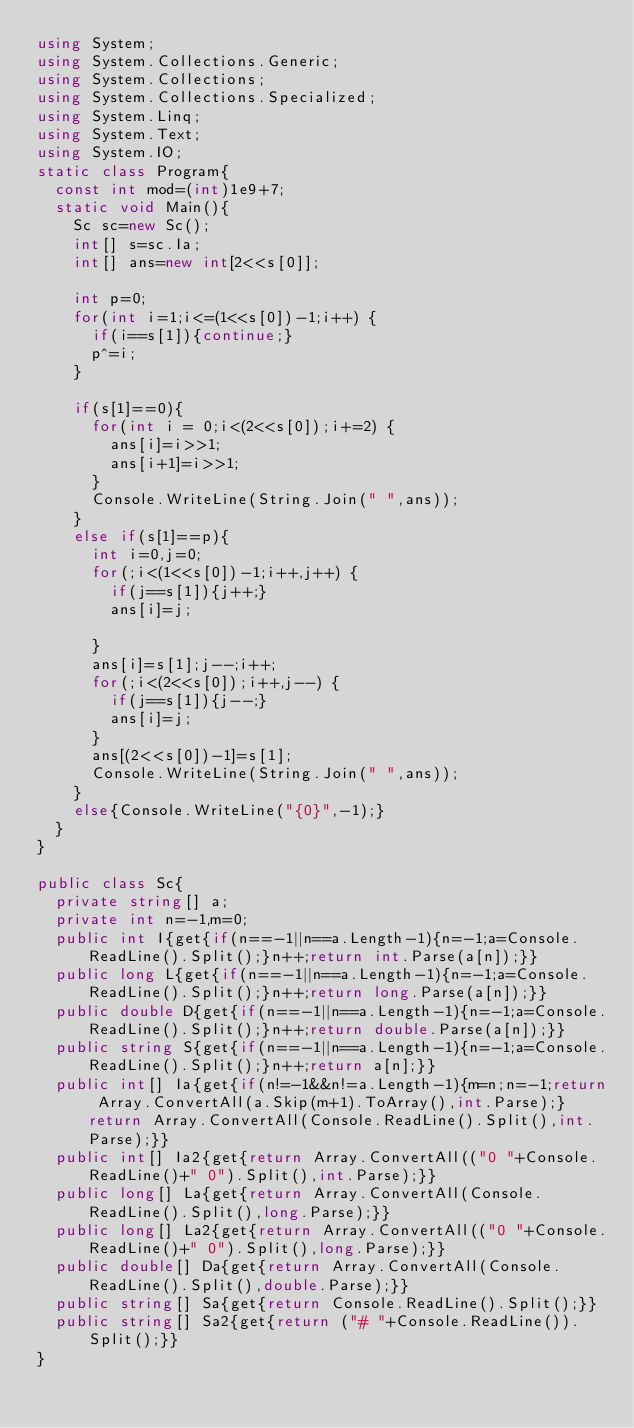Convert code to text. <code><loc_0><loc_0><loc_500><loc_500><_C#_>using System;
using System.Collections.Generic;
using System.Collections;
using System.Collections.Specialized;
using System.Linq;
using System.Text;
using System.IO;
static class Program{
	const int mod=(int)1e9+7;
	static void Main(){
		Sc sc=new Sc();
		int[] s=sc.Ia;
		int[] ans=new int[2<<s[0]];
		
		int p=0;
		for(int i=1;i<=(1<<s[0])-1;i++) {
			if(i==s[1]){continue;}
			p^=i;
		}
		
		if(s[1]==0){
			for(int i = 0;i<(2<<s[0]);i+=2) {
				ans[i]=i>>1;
				ans[i+1]=i>>1;
			}
			Console.WriteLine(String.Join(" ",ans));
		}
		else if(s[1]==p){
			int i=0,j=0;
			for(;i<(1<<s[0])-1;i++,j++) {
				if(j==s[1]){j++;}
				ans[i]=j;
				
			}
			ans[i]=s[1];j--;i++;
			for(;i<(2<<s[0]);i++,j--) {
				if(j==s[1]){j--;}
				ans[i]=j;
			}
			ans[(2<<s[0])-1]=s[1];
			Console.WriteLine(String.Join(" ",ans));
		}
		else{Console.WriteLine("{0}",-1);}
	}
}

public class Sc{
	private string[] a;
	private int n=-1,m=0;
	public int I{get{if(n==-1||n==a.Length-1){n=-1;a=Console.ReadLine().Split();}n++;return int.Parse(a[n]);}}
	public long L{get{if(n==-1||n==a.Length-1){n=-1;a=Console.ReadLine().Split();}n++;return long.Parse(a[n]);}}
	public double D{get{if(n==-1||n==a.Length-1){n=-1;a=Console.ReadLine().Split();}n++;return double.Parse(a[n]);}}
	public string S{get{if(n==-1||n==a.Length-1){n=-1;a=Console.ReadLine().Split();}n++;return a[n];}}
	public int[] Ia{get{if(n!=-1&&n!=a.Length-1){m=n;n=-1;return Array.ConvertAll(a.Skip(m+1).ToArray(),int.Parse);}return Array.ConvertAll(Console.ReadLine().Split(),int.Parse);}}
	public int[] Ia2{get{return Array.ConvertAll(("0 "+Console.ReadLine()+" 0").Split(),int.Parse);}}
	public long[] La{get{return Array.ConvertAll(Console.ReadLine().Split(),long.Parse);}}
	public long[] La2{get{return Array.ConvertAll(("0 "+Console.ReadLine()+" 0").Split(),long.Parse);}}
	public double[] Da{get{return Array.ConvertAll(Console.ReadLine().Split(),double.Parse);}}
	public string[] Sa{get{return Console.ReadLine().Split();}}
	public string[] Sa2{get{return ("# "+Console.ReadLine()).Split();}}
}</code> 